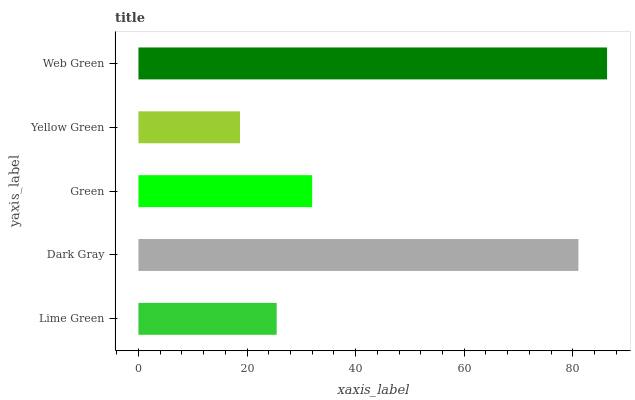Is Yellow Green the minimum?
Answer yes or no. Yes. Is Web Green the maximum?
Answer yes or no. Yes. Is Dark Gray the minimum?
Answer yes or no. No. Is Dark Gray the maximum?
Answer yes or no. No. Is Dark Gray greater than Lime Green?
Answer yes or no. Yes. Is Lime Green less than Dark Gray?
Answer yes or no. Yes. Is Lime Green greater than Dark Gray?
Answer yes or no. No. Is Dark Gray less than Lime Green?
Answer yes or no. No. Is Green the high median?
Answer yes or no. Yes. Is Green the low median?
Answer yes or no. Yes. Is Lime Green the high median?
Answer yes or no. No. Is Yellow Green the low median?
Answer yes or no. No. 